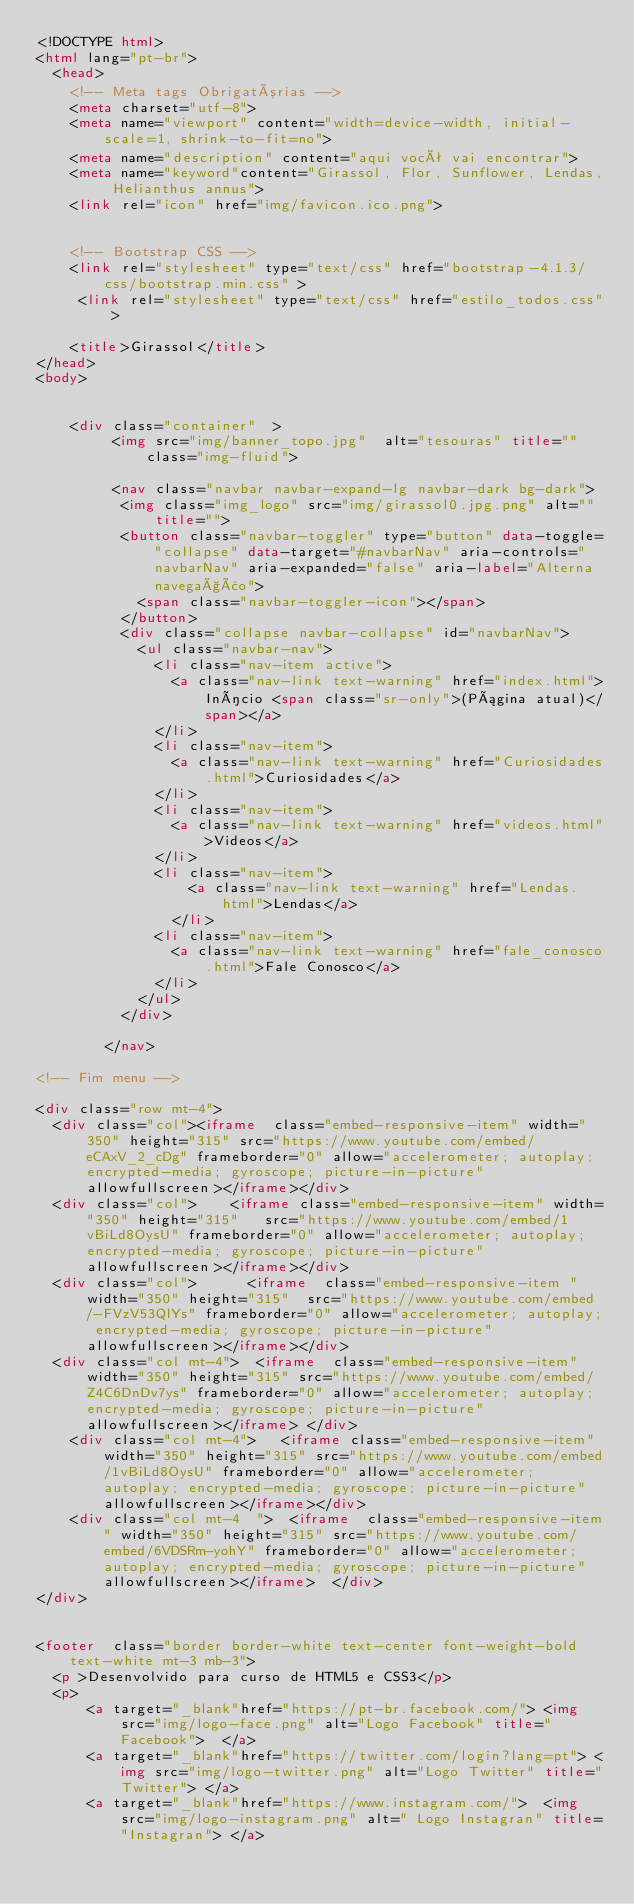Convert code to text. <code><loc_0><loc_0><loc_500><loc_500><_HTML_><!DOCTYPE html>
<html lang="pt-br">
  <head>
    <!-- Meta tags Obrigatórias -->
    <meta charset="utf-8">
    <meta name="viewport" content="width=device-width, initial-scale=1, shrink-to-fit=no">
    <meta name="description" content="aqui você vai encontrar">
    <meta name="keyword"content="Girassol, Flor, Sunflower, Lendas, Helianthus annus">
    <link rel="icon" href="img/favicon.ico.png">
    

    <!-- Bootstrap CSS -->
    <link rel="stylesheet" type="text/css" href="bootstrap-4.1.3/css/bootstrap.min.css" >
     <link rel="stylesheet" type="text/css" href="estilo_todos.css">
        
    <title>Girassol</title>
</head>
<body>


    <div class="container"  >
         <img src="img/banner_topo.jpg"  alt="tesouras" title="" class="img-fluid">

         <nav class="navbar navbar-expand-lg navbar-dark bg-dark">
          <img class="img_logo" src="img/girassol0.jpg.png" alt="" title="">
          <button class="navbar-toggler" type="button" data-toggle="collapse" data-target="#navbarNav" aria-controls="navbarNav" aria-expanded="false" aria-label="Alterna navegação">
            <span class="navbar-toggler-icon"></span>
          </button>
          <div class="collapse navbar-collapse" id="navbarNav">
            <ul class="navbar-nav">
              <li class="nav-item active">
                <a class="nav-link text-warning" href="index.html">Início <span class="sr-only">(Página atual)</span></a>
              </li>
              <li class="nav-item">
                <a class="nav-link text-warning" href="Curiosidades.html">Curiosidades</a>
              </li>
              <li class="nav-item">
                <a class="nav-link text-warning" href="videos.html">Videos</a>
              </li>
              <li class="nav-item">
                  <a class="nav-link text-warning" href="Lendas.html">Lendas</a>
                </li>
              <li class="nav-item">
                <a class="nav-link text-warning" href="fale_conosco.html">Fale Conosco</a>
              </li>
            </ul>
          </div>
      
        </nav>

<!-- Fim menu -->

<div class="row mt-4">
  <div class="col"><iframe  class="embed-responsive-item" width="350" height="315" src="https://www.youtube.com/embed/eCAxV_2_cDg" frameborder="0" allow="accelerometer; autoplay; encrypted-media; gyroscope; picture-in-picture" allowfullscreen></iframe></div>
  <div class="col">    <iframe class="embed-responsive-item" width="350" height="315"   src="https://www.youtube.com/embed/1vBiLd8OysU" frameborder="0" allow="accelerometer; autoplay; encrypted-media; gyroscope; picture-in-picture" allowfullscreen></iframe></div>
  <div class="col">      <iframe  class="embed-responsive-item " width="350" height="315"  src="https://www.youtube.com/embed/-FVzV53QlYs" frameborder="0" allow="accelerometer; autoplay; encrypted-media; gyroscope; picture-in-picture" allowfullscreen></iframe></div>
  <div class="col mt-4">  <iframe  class="embed-responsive-item" width="350" height="315" src="https://www.youtube.com/embed/Z4C6DnDv7ys" frameborder="0" allow="accelerometer; autoplay; encrypted-media; gyroscope; picture-in-picture" allowfullscreen></iframe> </div>
    <div class="col mt-4">   <iframe class="embed-responsive-item" width="350" height="315" src="https://www.youtube.com/embed/1vBiLd8OysU" frameborder="0" allow="accelerometer; autoplay; encrypted-media; gyroscope; picture-in-picture" allowfullscreen></iframe></div>
    <div class="col mt-4  ">  <iframe  class="embed-responsive-item" width="350" height="315" src="https://www.youtube.com/embed/6VDSRm-yohY" frameborder="0" allow="accelerometer; autoplay; encrypted-media; gyroscope; picture-in-picture" allowfullscreen></iframe>  </div>
</div>


<footer  class="border border-white text-center font-weight-bold text-white mt-3 mb-3">
  <p >Desenvolvido para curso de HTML5 e CSS3</p>
  <p>
      <a target="_blank"href="https://pt-br.facebook.com/"> <img src="img/logo-face.png" alt="Logo Facebook" title="Facebook">  </a>
      <a target="_blank"href="https://twitter.com/login?lang=pt"> <img src="img/logo-twitter.png" alt="Logo Twitter" title="Twitter"> </a>
      <a target="_blank"href="https://www.instagram.com/">  <img src="img/logo-instagram.png" alt=" Logo Instagran" title="Instagran"> </a></code> 